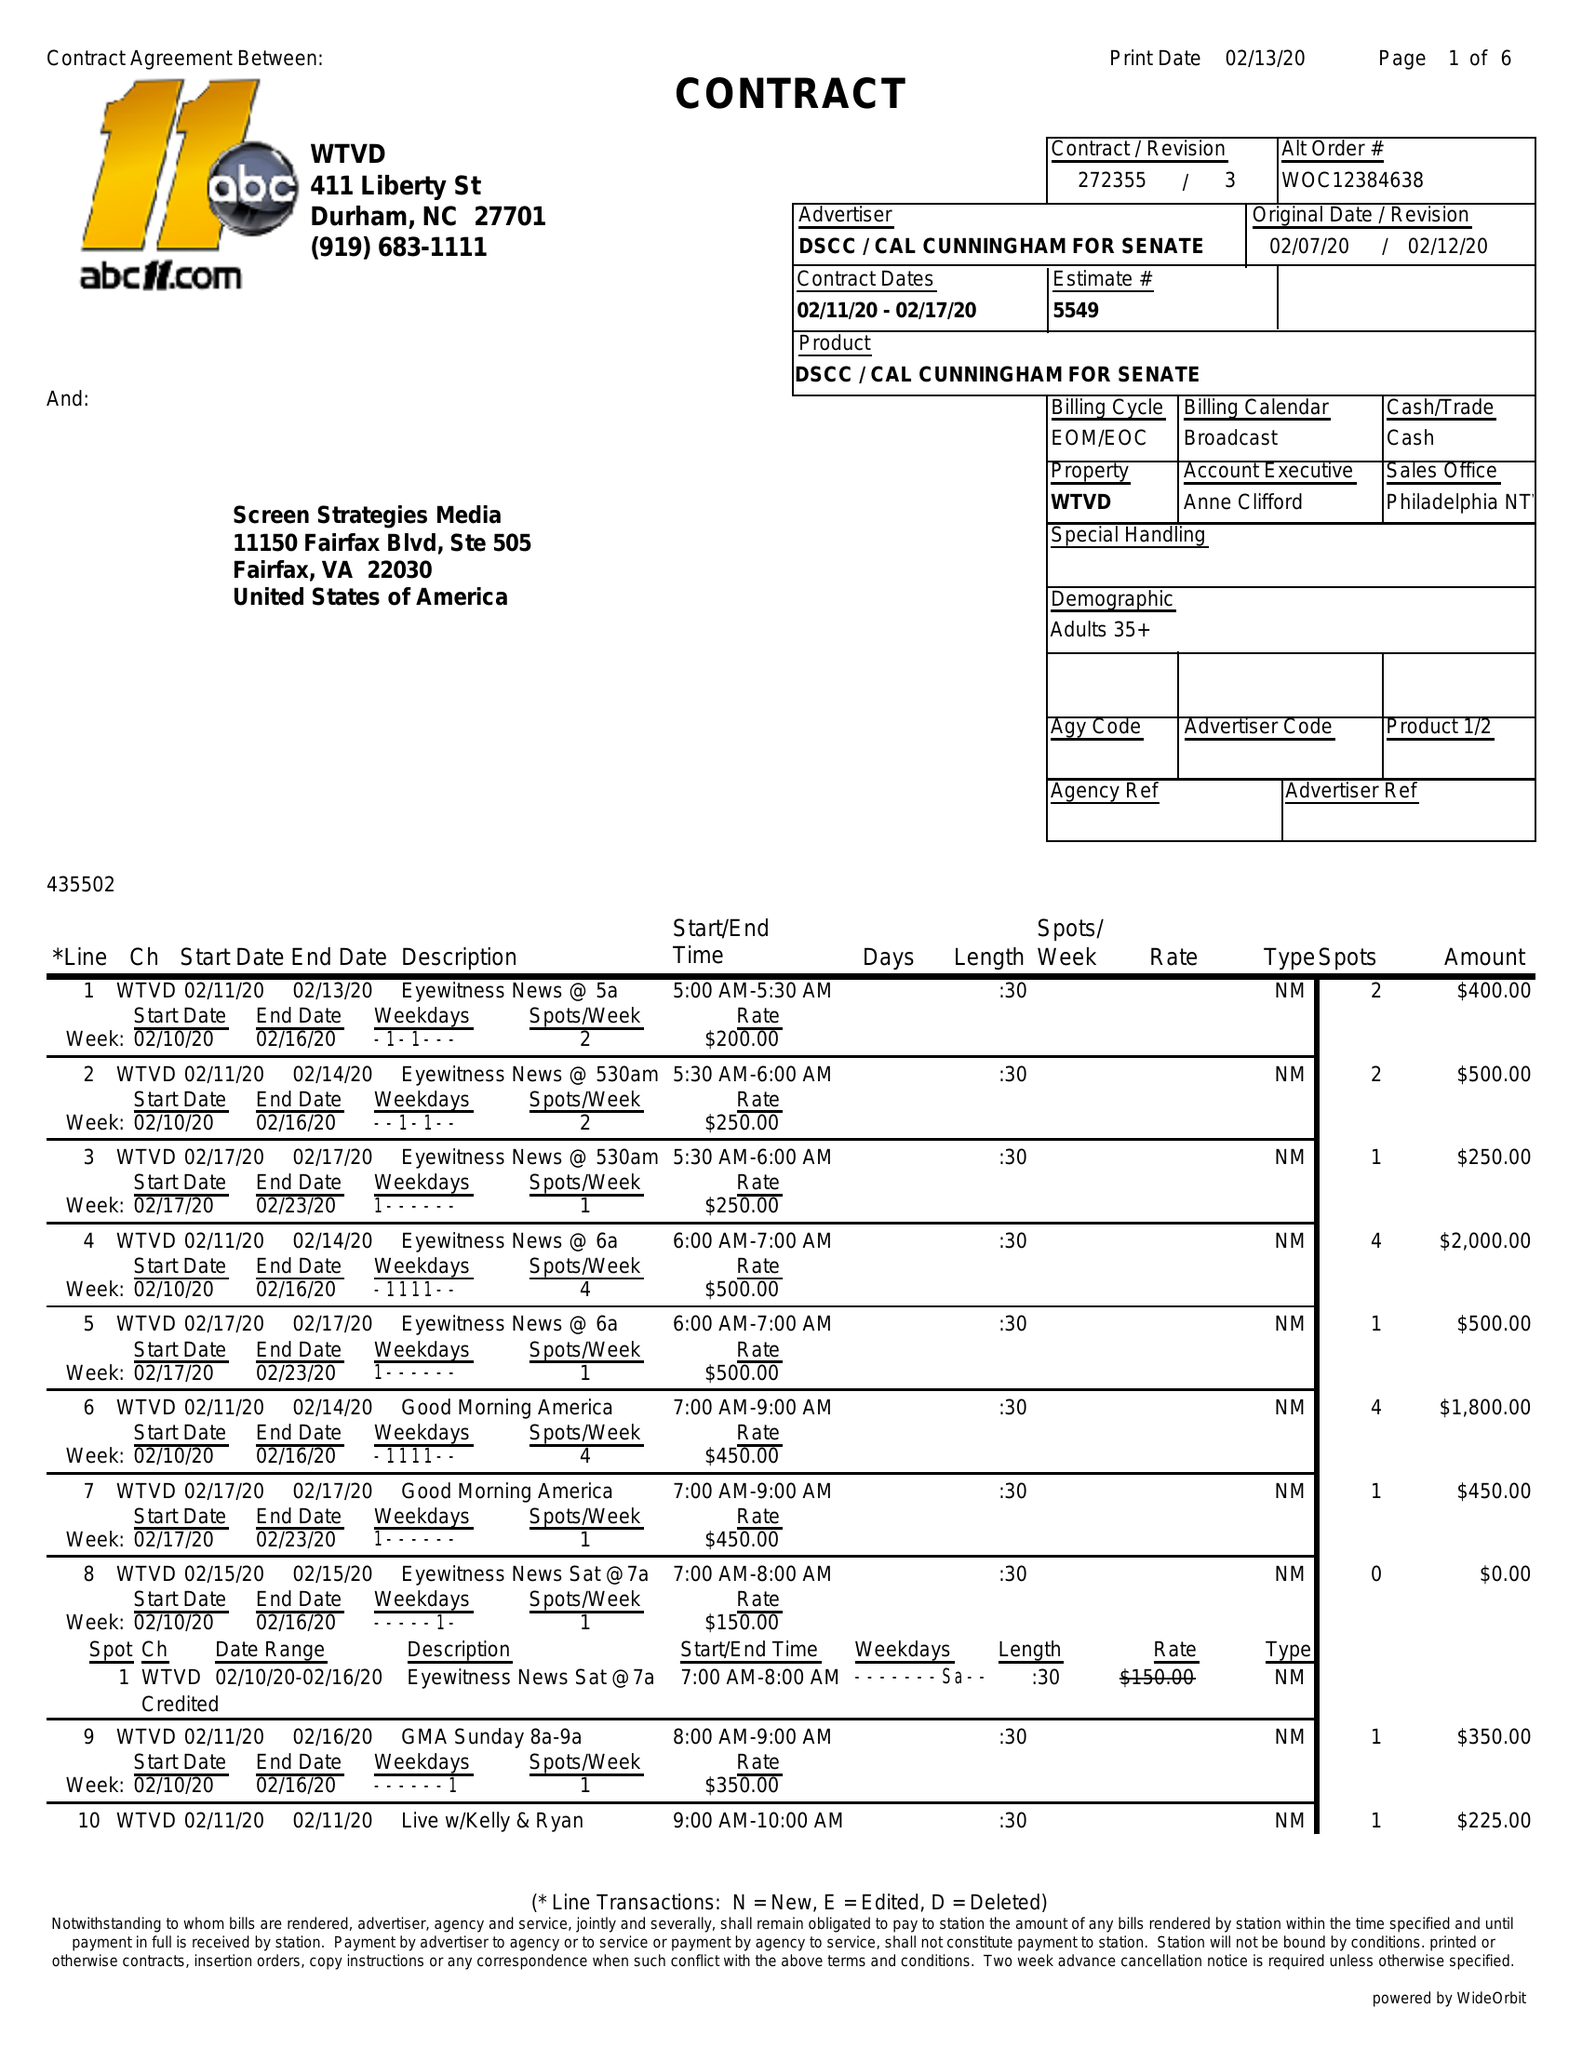What is the value for the contract_num?
Answer the question using a single word or phrase. 272355/3 